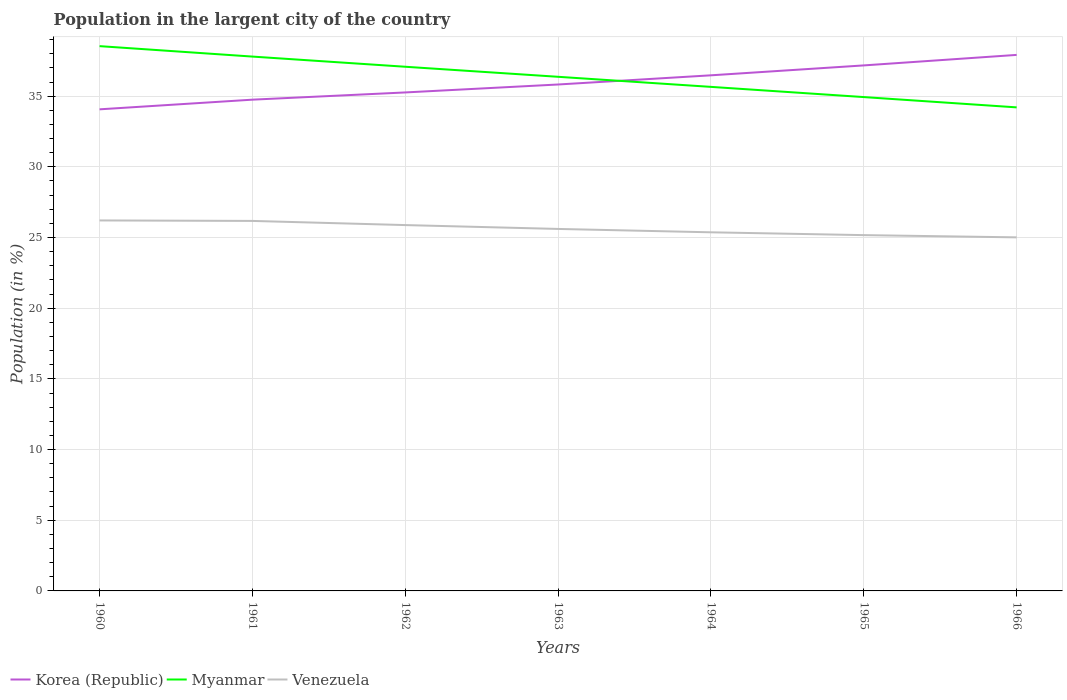How many different coloured lines are there?
Offer a terse response. 3. Across all years, what is the maximum percentage of population in the largent city in Venezuela?
Your answer should be compact. 25.01. In which year was the percentage of population in the largent city in Myanmar maximum?
Offer a very short reply. 1966. What is the total percentage of population in the largent city in Venezuela in the graph?
Offer a very short reply. 0.03. What is the difference between the highest and the second highest percentage of population in the largent city in Venezuela?
Provide a short and direct response. 1.2. How many years are there in the graph?
Give a very brief answer. 7. What is the difference between two consecutive major ticks on the Y-axis?
Provide a succinct answer. 5. Does the graph contain any zero values?
Ensure brevity in your answer.  No. Does the graph contain grids?
Make the answer very short. Yes. How are the legend labels stacked?
Provide a succinct answer. Horizontal. What is the title of the graph?
Your answer should be compact. Population in the largent city of the country. What is the label or title of the X-axis?
Ensure brevity in your answer.  Years. What is the Population (in %) in Korea (Republic) in 1960?
Ensure brevity in your answer.  34.07. What is the Population (in %) of Myanmar in 1960?
Offer a terse response. 38.54. What is the Population (in %) in Venezuela in 1960?
Your answer should be compact. 26.21. What is the Population (in %) in Korea (Republic) in 1961?
Keep it short and to the point. 34.75. What is the Population (in %) of Myanmar in 1961?
Make the answer very short. 37.8. What is the Population (in %) in Venezuela in 1961?
Your answer should be very brief. 26.17. What is the Population (in %) of Korea (Republic) in 1962?
Your answer should be compact. 35.26. What is the Population (in %) of Myanmar in 1962?
Offer a very short reply. 37.08. What is the Population (in %) of Venezuela in 1962?
Your response must be concise. 25.88. What is the Population (in %) in Korea (Republic) in 1963?
Make the answer very short. 35.82. What is the Population (in %) of Myanmar in 1963?
Give a very brief answer. 36.37. What is the Population (in %) of Venezuela in 1963?
Provide a short and direct response. 25.61. What is the Population (in %) of Korea (Republic) in 1964?
Ensure brevity in your answer.  36.47. What is the Population (in %) of Myanmar in 1964?
Offer a terse response. 35.66. What is the Population (in %) in Venezuela in 1964?
Your answer should be very brief. 25.37. What is the Population (in %) in Korea (Republic) in 1965?
Your response must be concise. 37.17. What is the Population (in %) of Myanmar in 1965?
Make the answer very short. 34.93. What is the Population (in %) of Venezuela in 1965?
Offer a very short reply. 25.17. What is the Population (in %) of Korea (Republic) in 1966?
Provide a succinct answer. 37.92. What is the Population (in %) of Myanmar in 1966?
Provide a succinct answer. 34.21. What is the Population (in %) of Venezuela in 1966?
Offer a terse response. 25.01. Across all years, what is the maximum Population (in %) of Korea (Republic)?
Offer a very short reply. 37.92. Across all years, what is the maximum Population (in %) of Myanmar?
Offer a terse response. 38.54. Across all years, what is the maximum Population (in %) in Venezuela?
Give a very brief answer. 26.21. Across all years, what is the minimum Population (in %) of Korea (Republic)?
Provide a short and direct response. 34.07. Across all years, what is the minimum Population (in %) in Myanmar?
Give a very brief answer. 34.21. Across all years, what is the minimum Population (in %) of Venezuela?
Give a very brief answer. 25.01. What is the total Population (in %) of Korea (Republic) in the graph?
Ensure brevity in your answer.  251.47. What is the total Population (in %) of Myanmar in the graph?
Provide a succinct answer. 254.58. What is the total Population (in %) of Venezuela in the graph?
Ensure brevity in your answer.  179.42. What is the difference between the Population (in %) of Korea (Republic) in 1960 and that in 1961?
Keep it short and to the point. -0.68. What is the difference between the Population (in %) of Myanmar in 1960 and that in 1961?
Make the answer very short. 0.74. What is the difference between the Population (in %) of Venezuela in 1960 and that in 1961?
Give a very brief answer. 0.03. What is the difference between the Population (in %) in Korea (Republic) in 1960 and that in 1962?
Keep it short and to the point. -1.19. What is the difference between the Population (in %) in Myanmar in 1960 and that in 1962?
Offer a very short reply. 1.46. What is the difference between the Population (in %) in Venezuela in 1960 and that in 1962?
Your answer should be very brief. 0.33. What is the difference between the Population (in %) in Korea (Republic) in 1960 and that in 1963?
Your response must be concise. -1.76. What is the difference between the Population (in %) of Myanmar in 1960 and that in 1963?
Ensure brevity in your answer.  2.17. What is the difference between the Population (in %) in Venezuela in 1960 and that in 1963?
Ensure brevity in your answer.  0.6. What is the difference between the Population (in %) of Korea (Republic) in 1960 and that in 1964?
Ensure brevity in your answer.  -2.41. What is the difference between the Population (in %) in Myanmar in 1960 and that in 1964?
Your answer should be compact. 2.88. What is the difference between the Population (in %) in Venezuela in 1960 and that in 1964?
Offer a terse response. 0.84. What is the difference between the Population (in %) of Korea (Republic) in 1960 and that in 1965?
Your response must be concise. -3.11. What is the difference between the Population (in %) of Myanmar in 1960 and that in 1965?
Give a very brief answer. 3.6. What is the difference between the Population (in %) in Venezuela in 1960 and that in 1965?
Your response must be concise. 1.04. What is the difference between the Population (in %) in Korea (Republic) in 1960 and that in 1966?
Ensure brevity in your answer.  -3.85. What is the difference between the Population (in %) of Myanmar in 1960 and that in 1966?
Your answer should be very brief. 4.33. What is the difference between the Population (in %) of Venezuela in 1960 and that in 1966?
Your answer should be compact. 1.2. What is the difference between the Population (in %) in Korea (Republic) in 1961 and that in 1962?
Provide a succinct answer. -0.51. What is the difference between the Population (in %) of Myanmar in 1961 and that in 1962?
Your response must be concise. 0.72. What is the difference between the Population (in %) in Venezuela in 1961 and that in 1962?
Your answer should be very brief. 0.29. What is the difference between the Population (in %) in Korea (Republic) in 1961 and that in 1963?
Provide a short and direct response. -1.07. What is the difference between the Population (in %) in Myanmar in 1961 and that in 1963?
Provide a short and direct response. 1.43. What is the difference between the Population (in %) in Venezuela in 1961 and that in 1963?
Give a very brief answer. 0.57. What is the difference between the Population (in %) of Korea (Republic) in 1961 and that in 1964?
Provide a short and direct response. -1.72. What is the difference between the Population (in %) in Myanmar in 1961 and that in 1964?
Make the answer very short. 2.14. What is the difference between the Population (in %) of Venezuela in 1961 and that in 1964?
Provide a short and direct response. 0.81. What is the difference between the Population (in %) of Korea (Republic) in 1961 and that in 1965?
Offer a very short reply. -2.42. What is the difference between the Population (in %) in Myanmar in 1961 and that in 1965?
Provide a short and direct response. 2.86. What is the difference between the Population (in %) of Venezuela in 1961 and that in 1965?
Your answer should be compact. 1. What is the difference between the Population (in %) in Korea (Republic) in 1961 and that in 1966?
Make the answer very short. -3.17. What is the difference between the Population (in %) in Myanmar in 1961 and that in 1966?
Provide a short and direct response. 3.59. What is the difference between the Population (in %) in Venezuela in 1961 and that in 1966?
Keep it short and to the point. 1.16. What is the difference between the Population (in %) in Korea (Republic) in 1962 and that in 1963?
Provide a succinct answer. -0.56. What is the difference between the Population (in %) in Myanmar in 1962 and that in 1963?
Your answer should be compact. 0.71. What is the difference between the Population (in %) in Venezuela in 1962 and that in 1963?
Make the answer very short. 0.27. What is the difference between the Population (in %) of Korea (Republic) in 1962 and that in 1964?
Provide a succinct answer. -1.21. What is the difference between the Population (in %) of Myanmar in 1962 and that in 1964?
Keep it short and to the point. 1.42. What is the difference between the Population (in %) of Venezuela in 1962 and that in 1964?
Keep it short and to the point. 0.51. What is the difference between the Population (in %) of Korea (Republic) in 1962 and that in 1965?
Offer a very short reply. -1.91. What is the difference between the Population (in %) of Myanmar in 1962 and that in 1965?
Offer a very short reply. 2.15. What is the difference between the Population (in %) in Venezuela in 1962 and that in 1965?
Give a very brief answer. 0.71. What is the difference between the Population (in %) of Korea (Republic) in 1962 and that in 1966?
Provide a short and direct response. -2.66. What is the difference between the Population (in %) of Myanmar in 1962 and that in 1966?
Give a very brief answer. 2.87. What is the difference between the Population (in %) in Venezuela in 1962 and that in 1966?
Provide a short and direct response. 0.87. What is the difference between the Population (in %) in Korea (Republic) in 1963 and that in 1964?
Offer a terse response. -0.65. What is the difference between the Population (in %) in Myanmar in 1963 and that in 1964?
Ensure brevity in your answer.  0.71. What is the difference between the Population (in %) of Venezuela in 1963 and that in 1964?
Your answer should be compact. 0.24. What is the difference between the Population (in %) in Korea (Republic) in 1963 and that in 1965?
Offer a very short reply. -1.35. What is the difference between the Population (in %) of Myanmar in 1963 and that in 1965?
Your response must be concise. 1.43. What is the difference between the Population (in %) in Venezuela in 1963 and that in 1965?
Offer a very short reply. 0.44. What is the difference between the Population (in %) of Korea (Republic) in 1963 and that in 1966?
Give a very brief answer. -2.09. What is the difference between the Population (in %) in Myanmar in 1963 and that in 1966?
Give a very brief answer. 2.16. What is the difference between the Population (in %) of Venezuela in 1963 and that in 1966?
Offer a terse response. 0.6. What is the difference between the Population (in %) of Korea (Republic) in 1964 and that in 1965?
Provide a succinct answer. -0.7. What is the difference between the Population (in %) of Myanmar in 1964 and that in 1965?
Ensure brevity in your answer.  0.72. What is the difference between the Population (in %) of Venezuela in 1964 and that in 1965?
Your response must be concise. 0.2. What is the difference between the Population (in %) of Korea (Republic) in 1964 and that in 1966?
Ensure brevity in your answer.  -1.44. What is the difference between the Population (in %) of Myanmar in 1964 and that in 1966?
Offer a very short reply. 1.45. What is the difference between the Population (in %) in Venezuela in 1964 and that in 1966?
Your answer should be compact. 0.36. What is the difference between the Population (in %) of Korea (Republic) in 1965 and that in 1966?
Provide a succinct answer. -0.74. What is the difference between the Population (in %) of Myanmar in 1965 and that in 1966?
Keep it short and to the point. 0.73. What is the difference between the Population (in %) of Venezuela in 1965 and that in 1966?
Provide a short and direct response. 0.16. What is the difference between the Population (in %) in Korea (Republic) in 1960 and the Population (in %) in Myanmar in 1961?
Your response must be concise. -3.73. What is the difference between the Population (in %) of Korea (Republic) in 1960 and the Population (in %) of Venezuela in 1961?
Offer a terse response. 7.89. What is the difference between the Population (in %) of Myanmar in 1960 and the Population (in %) of Venezuela in 1961?
Offer a terse response. 12.36. What is the difference between the Population (in %) in Korea (Republic) in 1960 and the Population (in %) in Myanmar in 1962?
Provide a short and direct response. -3.01. What is the difference between the Population (in %) of Korea (Republic) in 1960 and the Population (in %) of Venezuela in 1962?
Your response must be concise. 8.19. What is the difference between the Population (in %) in Myanmar in 1960 and the Population (in %) in Venezuela in 1962?
Ensure brevity in your answer.  12.66. What is the difference between the Population (in %) of Korea (Republic) in 1960 and the Population (in %) of Myanmar in 1963?
Your answer should be very brief. -2.3. What is the difference between the Population (in %) of Korea (Republic) in 1960 and the Population (in %) of Venezuela in 1963?
Your response must be concise. 8.46. What is the difference between the Population (in %) of Myanmar in 1960 and the Population (in %) of Venezuela in 1963?
Offer a very short reply. 12.93. What is the difference between the Population (in %) of Korea (Republic) in 1960 and the Population (in %) of Myanmar in 1964?
Offer a very short reply. -1.59. What is the difference between the Population (in %) in Korea (Republic) in 1960 and the Population (in %) in Venezuela in 1964?
Provide a short and direct response. 8.7. What is the difference between the Population (in %) of Myanmar in 1960 and the Population (in %) of Venezuela in 1964?
Ensure brevity in your answer.  13.17. What is the difference between the Population (in %) in Korea (Republic) in 1960 and the Population (in %) in Myanmar in 1965?
Offer a very short reply. -0.87. What is the difference between the Population (in %) in Korea (Republic) in 1960 and the Population (in %) in Venezuela in 1965?
Ensure brevity in your answer.  8.9. What is the difference between the Population (in %) of Myanmar in 1960 and the Population (in %) of Venezuela in 1965?
Your response must be concise. 13.37. What is the difference between the Population (in %) in Korea (Republic) in 1960 and the Population (in %) in Myanmar in 1966?
Your response must be concise. -0.14. What is the difference between the Population (in %) in Korea (Republic) in 1960 and the Population (in %) in Venezuela in 1966?
Make the answer very short. 9.06. What is the difference between the Population (in %) of Myanmar in 1960 and the Population (in %) of Venezuela in 1966?
Your response must be concise. 13.53. What is the difference between the Population (in %) of Korea (Republic) in 1961 and the Population (in %) of Myanmar in 1962?
Offer a very short reply. -2.33. What is the difference between the Population (in %) of Korea (Republic) in 1961 and the Population (in %) of Venezuela in 1962?
Your answer should be very brief. 8.87. What is the difference between the Population (in %) of Myanmar in 1961 and the Population (in %) of Venezuela in 1962?
Your answer should be very brief. 11.92. What is the difference between the Population (in %) of Korea (Republic) in 1961 and the Population (in %) of Myanmar in 1963?
Provide a short and direct response. -1.62. What is the difference between the Population (in %) of Korea (Republic) in 1961 and the Population (in %) of Venezuela in 1963?
Your answer should be compact. 9.14. What is the difference between the Population (in %) in Myanmar in 1961 and the Population (in %) in Venezuela in 1963?
Make the answer very short. 12.19. What is the difference between the Population (in %) of Korea (Republic) in 1961 and the Population (in %) of Myanmar in 1964?
Your answer should be very brief. -0.9. What is the difference between the Population (in %) in Korea (Republic) in 1961 and the Population (in %) in Venezuela in 1964?
Provide a succinct answer. 9.38. What is the difference between the Population (in %) of Myanmar in 1961 and the Population (in %) of Venezuela in 1964?
Give a very brief answer. 12.43. What is the difference between the Population (in %) in Korea (Republic) in 1961 and the Population (in %) in Myanmar in 1965?
Keep it short and to the point. -0.18. What is the difference between the Population (in %) of Korea (Republic) in 1961 and the Population (in %) of Venezuela in 1965?
Provide a succinct answer. 9.58. What is the difference between the Population (in %) in Myanmar in 1961 and the Population (in %) in Venezuela in 1965?
Make the answer very short. 12.63. What is the difference between the Population (in %) in Korea (Republic) in 1961 and the Population (in %) in Myanmar in 1966?
Make the answer very short. 0.55. What is the difference between the Population (in %) of Korea (Republic) in 1961 and the Population (in %) of Venezuela in 1966?
Provide a short and direct response. 9.74. What is the difference between the Population (in %) of Myanmar in 1961 and the Population (in %) of Venezuela in 1966?
Make the answer very short. 12.79. What is the difference between the Population (in %) in Korea (Republic) in 1962 and the Population (in %) in Myanmar in 1963?
Provide a short and direct response. -1.11. What is the difference between the Population (in %) in Korea (Republic) in 1962 and the Population (in %) in Venezuela in 1963?
Your response must be concise. 9.66. What is the difference between the Population (in %) in Myanmar in 1962 and the Population (in %) in Venezuela in 1963?
Make the answer very short. 11.47. What is the difference between the Population (in %) of Korea (Republic) in 1962 and the Population (in %) of Myanmar in 1964?
Give a very brief answer. -0.39. What is the difference between the Population (in %) in Korea (Republic) in 1962 and the Population (in %) in Venezuela in 1964?
Provide a succinct answer. 9.89. What is the difference between the Population (in %) in Myanmar in 1962 and the Population (in %) in Venezuela in 1964?
Your answer should be very brief. 11.71. What is the difference between the Population (in %) of Korea (Republic) in 1962 and the Population (in %) of Myanmar in 1965?
Your response must be concise. 0.33. What is the difference between the Population (in %) of Korea (Republic) in 1962 and the Population (in %) of Venezuela in 1965?
Keep it short and to the point. 10.09. What is the difference between the Population (in %) of Myanmar in 1962 and the Population (in %) of Venezuela in 1965?
Ensure brevity in your answer.  11.91. What is the difference between the Population (in %) in Korea (Republic) in 1962 and the Population (in %) in Myanmar in 1966?
Provide a short and direct response. 1.06. What is the difference between the Population (in %) in Korea (Republic) in 1962 and the Population (in %) in Venezuela in 1966?
Provide a succinct answer. 10.25. What is the difference between the Population (in %) of Myanmar in 1962 and the Population (in %) of Venezuela in 1966?
Ensure brevity in your answer.  12.07. What is the difference between the Population (in %) in Korea (Republic) in 1963 and the Population (in %) in Myanmar in 1964?
Your answer should be compact. 0.17. What is the difference between the Population (in %) in Korea (Republic) in 1963 and the Population (in %) in Venezuela in 1964?
Provide a succinct answer. 10.46. What is the difference between the Population (in %) in Myanmar in 1963 and the Population (in %) in Venezuela in 1964?
Ensure brevity in your answer.  11. What is the difference between the Population (in %) of Korea (Republic) in 1963 and the Population (in %) of Myanmar in 1965?
Provide a short and direct response. 0.89. What is the difference between the Population (in %) of Korea (Republic) in 1963 and the Population (in %) of Venezuela in 1965?
Your response must be concise. 10.66. What is the difference between the Population (in %) in Myanmar in 1963 and the Population (in %) in Venezuela in 1965?
Offer a terse response. 11.2. What is the difference between the Population (in %) in Korea (Republic) in 1963 and the Population (in %) in Myanmar in 1966?
Offer a terse response. 1.62. What is the difference between the Population (in %) in Korea (Republic) in 1963 and the Population (in %) in Venezuela in 1966?
Make the answer very short. 10.81. What is the difference between the Population (in %) of Myanmar in 1963 and the Population (in %) of Venezuela in 1966?
Keep it short and to the point. 11.36. What is the difference between the Population (in %) in Korea (Republic) in 1964 and the Population (in %) in Myanmar in 1965?
Your answer should be very brief. 1.54. What is the difference between the Population (in %) in Korea (Republic) in 1964 and the Population (in %) in Venezuela in 1965?
Your answer should be compact. 11.3. What is the difference between the Population (in %) of Myanmar in 1964 and the Population (in %) of Venezuela in 1965?
Give a very brief answer. 10.49. What is the difference between the Population (in %) of Korea (Republic) in 1964 and the Population (in %) of Myanmar in 1966?
Your answer should be very brief. 2.27. What is the difference between the Population (in %) of Korea (Republic) in 1964 and the Population (in %) of Venezuela in 1966?
Provide a short and direct response. 11.46. What is the difference between the Population (in %) of Myanmar in 1964 and the Population (in %) of Venezuela in 1966?
Provide a short and direct response. 10.65. What is the difference between the Population (in %) of Korea (Republic) in 1965 and the Population (in %) of Myanmar in 1966?
Provide a succinct answer. 2.97. What is the difference between the Population (in %) in Korea (Republic) in 1965 and the Population (in %) in Venezuela in 1966?
Offer a terse response. 12.16. What is the difference between the Population (in %) in Myanmar in 1965 and the Population (in %) in Venezuela in 1966?
Offer a terse response. 9.92. What is the average Population (in %) of Korea (Republic) per year?
Keep it short and to the point. 35.92. What is the average Population (in %) in Myanmar per year?
Your answer should be compact. 36.37. What is the average Population (in %) in Venezuela per year?
Make the answer very short. 25.63. In the year 1960, what is the difference between the Population (in %) in Korea (Republic) and Population (in %) in Myanmar?
Keep it short and to the point. -4.47. In the year 1960, what is the difference between the Population (in %) of Korea (Republic) and Population (in %) of Venezuela?
Offer a very short reply. 7.86. In the year 1960, what is the difference between the Population (in %) in Myanmar and Population (in %) in Venezuela?
Your response must be concise. 12.33. In the year 1961, what is the difference between the Population (in %) of Korea (Republic) and Population (in %) of Myanmar?
Make the answer very short. -3.05. In the year 1961, what is the difference between the Population (in %) in Korea (Republic) and Population (in %) in Venezuela?
Your answer should be compact. 8.58. In the year 1961, what is the difference between the Population (in %) of Myanmar and Population (in %) of Venezuela?
Your answer should be very brief. 11.63. In the year 1962, what is the difference between the Population (in %) of Korea (Republic) and Population (in %) of Myanmar?
Offer a terse response. -1.82. In the year 1962, what is the difference between the Population (in %) of Korea (Republic) and Population (in %) of Venezuela?
Offer a terse response. 9.38. In the year 1962, what is the difference between the Population (in %) of Myanmar and Population (in %) of Venezuela?
Your answer should be very brief. 11.2. In the year 1963, what is the difference between the Population (in %) of Korea (Republic) and Population (in %) of Myanmar?
Offer a terse response. -0.54. In the year 1963, what is the difference between the Population (in %) in Korea (Republic) and Population (in %) in Venezuela?
Give a very brief answer. 10.22. In the year 1963, what is the difference between the Population (in %) of Myanmar and Population (in %) of Venezuela?
Offer a terse response. 10.76. In the year 1964, what is the difference between the Population (in %) in Korea (Republic) and Population (in %) in Myanmar?
Offer a very short reply. 0.82. In the year 1964, what is the difference between the Population (in %) in Korea (Republic) and Population (in %) in Venezuela?
Offer a terse response. 11.11. In the year 1964, what is the difference between the Population (in %) in Myanmar and Population (in %) in Venezuela?
Make the answer very short. 10.29. In the year 1965, what is the difference between the Population (in %) in Korea (Republic) and Population (in %) in Myanmar?
Your answer should be very brief. 2.24. In the year 1965, what is the difference between the Population (in %) in Korea (Republic) and Population (in %) in Venezuela?
Make the answer very short. 12.01. In the year 1965, what is the difference between the Population (in %) in Myanmar and Population (in %) in Venezuela?
Your answer should be very brief. 9.77. In the year 1966, what is the difference between the Population (in %) of Korea (Republic) and Population (in %) of Myanmar?
Your answer should be compact. 3.71. In the year 1966, what is the difference between the Population (in %) in Korea (Republic) and Population (in %) in Venezuela?
Your answer should be compact. 12.91. In the year 1966, what is the difference between the Population (in %) in Myanmar and Population (in %) in Venezuela?
Ensure brevity in your answer.  9.2. What is the ratio of the Population (in %) in Korea (Republic) in 1960 to that in 1961?
Keep it short and to the point. 0.98. What is the ratio of the Population (in %) in Myanmar in 1960 to that in 1961?
Provide a succinct answer. 1.02. What is the ratio of the Population (in %) in Korea (Republic) in 1960 to that in 1962?
Offer a terse response. 0.97. What is the ratio of the Population (in %) of Myanmar in 1960 to that in 1962?
Give a very brief answer. 1.04. What is the ratio of the Population (in %) in Venezuela in 1960 to that in 1962?
Your answer should be compact. 1.01. What is the ratio of the Population (in %) in Korea (Republic) in 1960 to that in 1963?
Give a very brief answer. 0.95. What is the ratio of the Population (in %) of Myanmar in 1960 to that in 1963?
Provide a succinct answer. 1.06. What is the ratio of the Population (in %) of Venezuela in 1960 to that in 1963?
Provide a short and direct response. 1.02. What is the ratio of the Population (in %) in Korea (Republic) in 1960 to that in 1964?
Give a very brief answer. 0.93. What is the ratio of the Population (in %) of Myanmar in 1960 to that in 1964?
Your response must be concise. 1.08. What is the ratio of the Population (in %) of Venezuela in 1960 to that in 1964?
Ensure brevity in your answer.  1.03. What is the ratio of the Population (in %) in Korea (Republic) in 1960 to that in 1965?
Provide a short and direct response. 0.92. What is the ratio of the Population (in %) of Myanmar in 1960 to that in 1965?
Your response must be concise. 1.1. What is the ratio of the Population (in %) of Venezuela in 1960 to that in 1965?
Provide a short and direct response. 1.04. What is the ratio of the Population (in %) of Korea (Republic) in 1960 to that in 1966?
Your response must be concise. 0.9. What is the ratio of the Population (in %) of Myanmar in 1960 to that in 1966?
Provide a succinct answer. 1.13. What is the ratio of the Population (in %) in Venezuela in 1960 to that in 1966?
Your response must be concise. 1.05. What is the ratio of the Population (in %) of Korea (Republic) in 1961 to that in 1962?
Provide a succinct answer. 0.99. What is the ratio of the Population (in %) in Myanmar in 1961 to that in 1962?
Provide a short and direct response. 1.02. What is the ratio of the Population (in %) of Venezuela in 1961 to that in 1962?
Provide a short and direct response. 1.01. What is the ratio of the Population (in %) in Myanmar in 1961 to that in 1963?
Ensure brevity in your answer.  1.04. What is the ratio of the Population (in %) in Venezuela in 1961 to that in 1963?
Provide a succinct answer. 1.02. What is the ratio of the Population (in %) in Korea (Republic) in 1961 to that in 1964?
Ensure brevity in your answer.  0.95. What is the ratio of the Population (in %) in Myanmar in 1961 to that in 1964?
Keep it short and to the point. 1.06. What is the ratio of the Population (in %) of Venezuela in 1961 to that in 1964?
Provide a short and direct response. 1.03. What is the ratio of the Population (in %) of Korea (Republic) in 1961 to that in 1965?
Ensure brevity in your answer.  0.93. What is the ratio of the Population (in %) in Myanmar in 1961 to that in 1965?
Provide a succinct answer. 1.08. What is the ratio of the Population (in %) in Venezuela in 1961 to that in 1965?
Ensure brevity in your answer.  1.04. What is the ratio of the Population (in %) in Korea (Republic) in 1961 to that in 1966?
Ensure brevity in your answer.  0.92. What is the ratio of the Population (in %) in Myanmar in 1961 to that in 1966?
Offer a very short reply. 1.1. What is the ratio of the Population (in %) in Venezuela in 1961 to that in 1966?
Keep it short and to the point. 1.05. What is the ratio of the Population (in %) in Korea (Republic) in 1962 to that in 1963?
Make the answer very short. 0.98. What is the ratio of the Population (in %) in Myanmar in 1962 to that in 1963?
Provide a succinct answer. 1.02. What is the ratio of the Population (in %) in Venezuela in 1962 to that in 1963?
Offer a very short reply. 1.01. What is the ratio of the Population (in %) of Korea (Republic) in 1962 to that in 1964?
Keep it short and to the point. 0.97. What is the ratio of the Population (in %) of Myanmar in 1962 to that in 1964?
Offer a very short reply. 1.04. What is the ratio of the Population (in %) in Venezuela in 1962 to that in 1964?
Your answer should be compact. 1.02. What is the ratio of the Population (in %) in Korea (Republic) in 1962 to that in 1965?
Give a very brief answer. 0.95. What is the ratio of the Population (in %) of Myanmar in 1962 to that in 1965?
Keep it short and to the point. 1.06. What is the ratio of the Population (in %) in Venezuela in 1962 to that in 1965?
Your answer should be compact. 1.03. What is the ratio of the Population (in %) in Korea (Republic) in 1962 to that in 1966?
Your answer should be compact. 0.93. What is the ratio of the Population (in %) in Myanmar in 1962 to that in 1966?
Your response must be concise. 1.08. What is the ratio of the Population (in %) of Venezuela in 1962 to that in 1966?
Your answer should be very brief. 1.03. What is the ratio of the Population (in %) of Korea (Republic) in 1963 to that in 1964?
Your answer should be very brief. 0.98. What is the ratio of the Population (in %) in Venezuela in 1963 to that in 1964?
Ensure brevity in your answer.  1.01. What is the ratio of the Population (in %) of Korea (Republic) in 1963 to that in 1965?
Keep it short and to the point. 0.96. What is the ratio of the Population (in %) of Myanmar in 1963 to that in 1965?
Give a very brief answer. 1.04. What is the ratio of the Population (in %) in Venezuela in 1963 to that in 1965?
Provide a short and direct response. 1.02. What is the ratio of the Population (in %) in Korea (Republic) in 1963 to that in 1966?
Offer a very short reply. 0.94. What is the ratio of the Population (in %) in Myanmar in 1963 to that in 1966?
Keep it short and to the point. 1.06. What is the ratio of the Population (in %) in Venezuela in 1963 to that in 1966?
Your response must be concise. 1.02. What is the ratio of the Population (in %) in Korea (Republic) in 1964 to that in 1965?
Your answer should be compact. 0.98. What is the ratio of the Population (in %) of Myanmar in 1964 to that in 1965?
Your answer should be compact. 1.02. What is the ratio of the Population (in %) in Venezuela in 1964 to that in 1965?
Ensure brevity in your answer.  1.01. What is the ratio of the Population (in %) in Korea (Republic) in 1964 to that in 1966?
Offer a terse response. 0.96. What is the ratio of the Population (in %) of Myanmar in 1964 to that in 1966?
Ensure brevity in your answer.  1.04. What is the ratio of the Population (in %) of Venezuela in 1964 to that in 1966?
Provide a succinct answer. 1.01. What is the ratio of the Population (in %) in Korea (Republic) in 1965 to that in 1966?
Give a very brief answer. 0.98. What is the ratio of the Population (in %) of Myanmar in 1965 to that in 1966?
Your answer should be very brief. 1.02. What is the ratio of the Population (in %) in Venezuela in 1965 to that in 1966?
Keep it short and to the point. 1.01. What is the difference between the highest and the second highest Population (in %) in Korea (Republic)?
Offer a very short reply. 0.74. What is the difference between the highest and the second highest Population (in %) of Myanmar?
Offer a terse response. 0.74. What is the difference between the highest and the second highest Population (in %) of Venezuela?
Ensure brevity in your answer.  0.03. What is the difference between the highest and the lowest Population (in %) in Korea (Republic)?
Ensure brevity in your answer.  3.85. What is the difference between the highest and the lowest Population (in %) of Myanmar?
Offer a very short reply. 4.33. What is the difference between the highest and the lowest Population (in %) of Venezuela?
Keep it short and to the point. 1.2. 